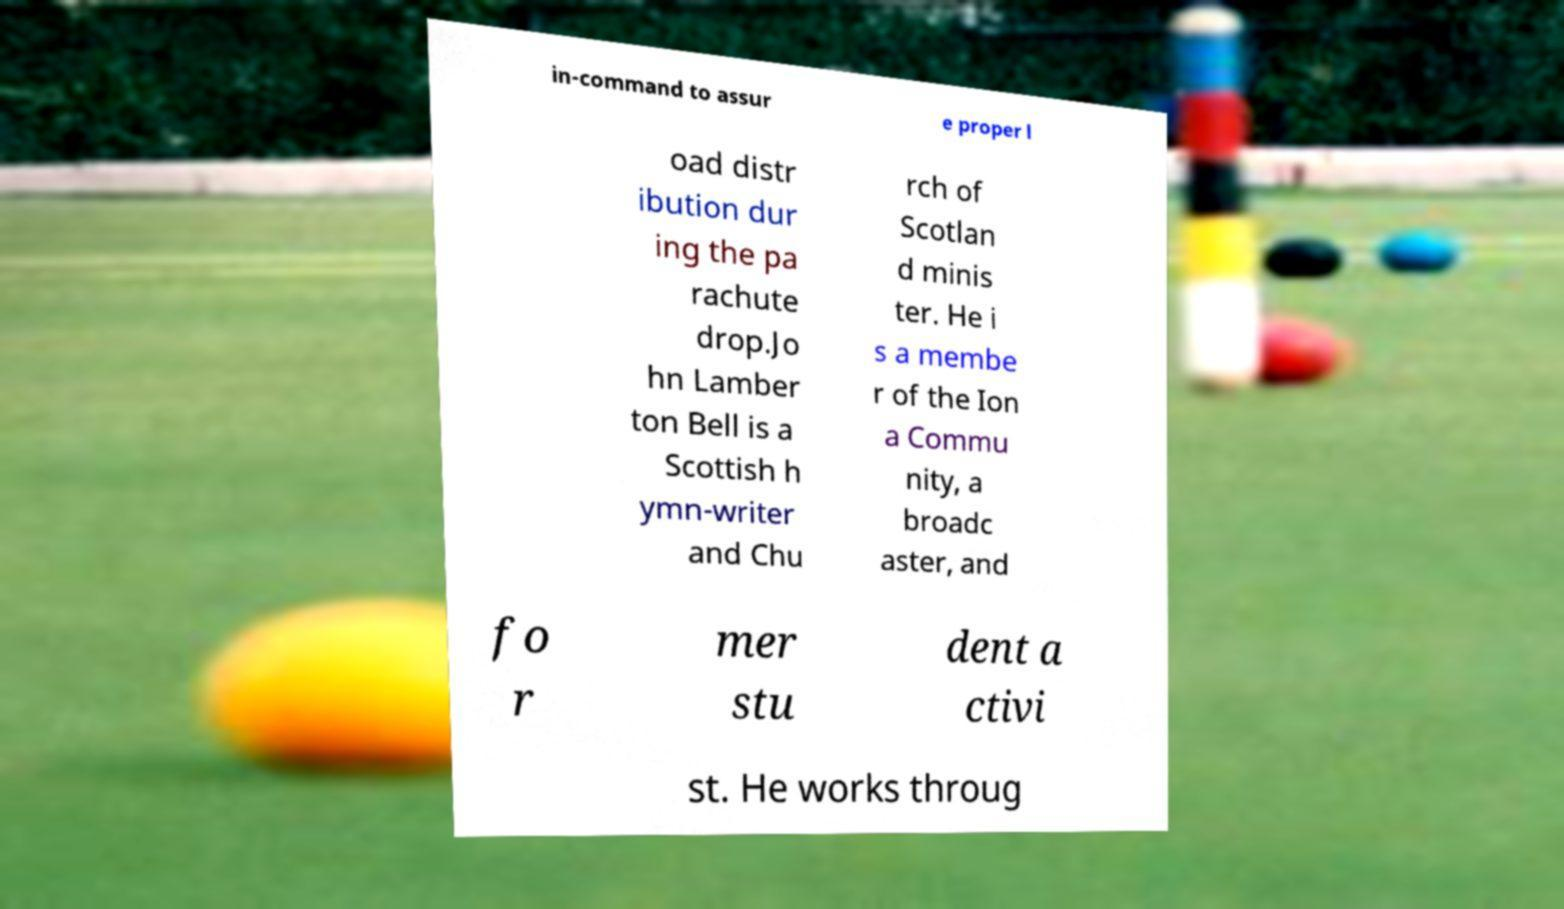For documentation purposes, I need the text within this image transcribed. Could you provide that? in-command to assur e proper l oad distr ibution dur ing the pa rachute drop.Jo hn Lamber ton Bell is a Scottish h ymn-writer and Chu rch of Scotlan d minis ter. He i s a membe r of the Ion a Commu nity, a broadc aster, and fo r mer stu dent a ctivi st. He works throug 